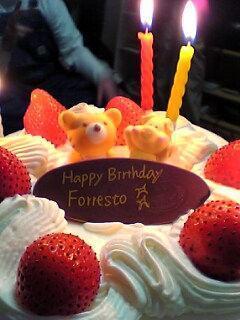Is this affirmation: "The teddy bear is on the cake." correct?
Answer yes or no. Yes. Verify the accuracy of this image caption: "The teddy bear is on top of the cake.".
Answer yes or no. Yes. 